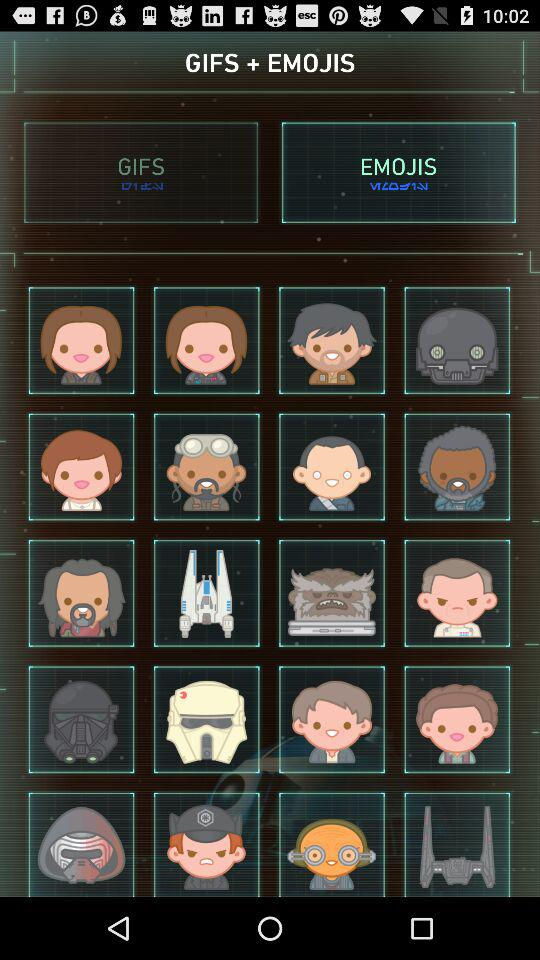Which tab is selected? The selected tab is "EMOJIS". 